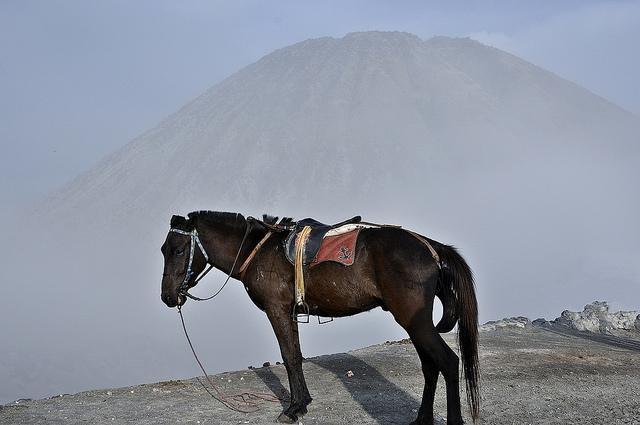How many people are wearing a red shirt?
Give a very brief answer. 0. 